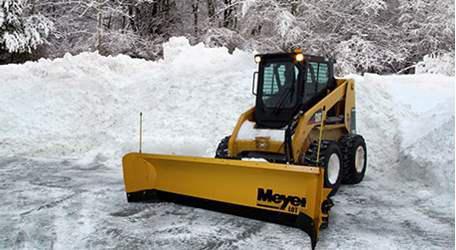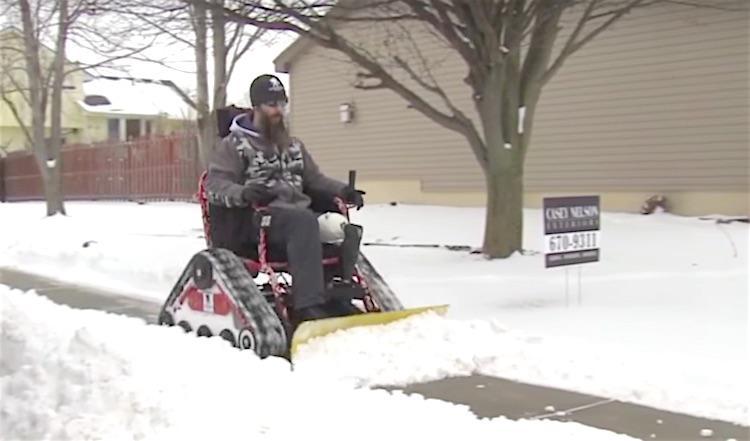The first image is the image on the left, the second image is the image on the right. Assess this claim about the two images: "The left and right image contains the same number of orange snow trucks.". Correct or not? Answer yes or no. No. The first image is the image on the left, the second image is the image on the right. Examine the images to the left and right. Is the description "At least one of the vehicles has its shovel tilted with the left side higher than the right" accurate? Answer yes or no. No. 